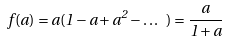<formula> <loc_0><loc_0><loc_500><loc_500>f ( a ) = a ( 1 - a + a ^ { 2 } - \dots \ ) = \frac { a } { 1 + a }</formula> 